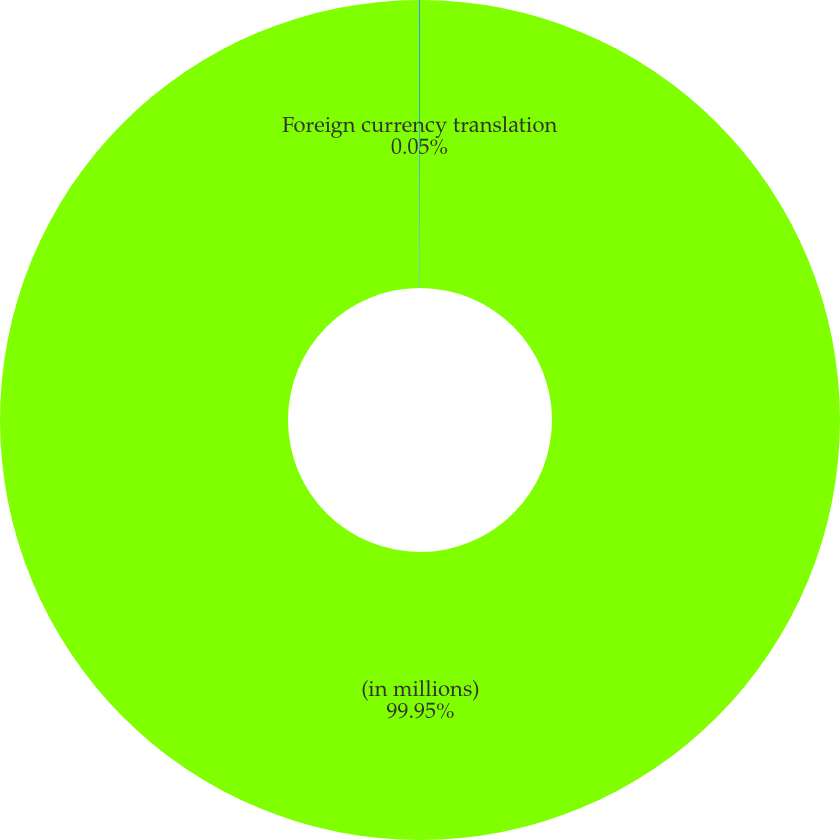Convert chart. <chart><loc_0><loc_0><loc_500><loc_500><pie_chart><fcel>(in millions)<fcel>Foreign currency translation<nl><fcel>99.95%<fcel>0.05%<nl></chart> 